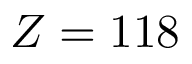<formula> <loc_0><loc_0><loc_500><loc_500>Z = 1 1 8</formula> 